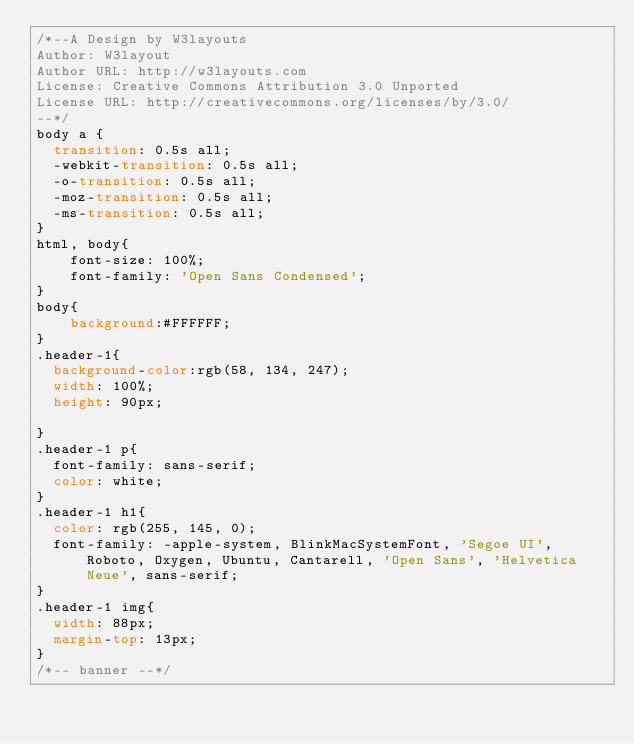Convert code to text. <code><loc_0><loc_0><loc_500><loc_500><_CSS_>/*--A Design by W3layouts 
Author: W3layout
Author URL: http://w3layouts.com
License: Creative Commons Attribution 3.0 Unported
License URL: http://creativecommons.org/licenses/by/3.0/
--*/
body a {
  transition: 0.5s all;
  -webkit-transition: 0.5s all;
  -o-transition: 0.5s all;
  -moz-transition: 0.5s all;
  -ms-transition: 0.5s all;
}
html, body{
    font-size: 100%;
	font-family: 'Open Sans Condensed';
}
body{
	background:#FFFFFF;
}
.header-1{
  background-color:rgb(58, 134, 247);
  width: 100%;
  height: 90px;
  
}
.header-1 p{
  font-family: sans-serif;
  color: white;
}
.header-1 h1{
  color: rgb(255, 145, 0);
  font-family: -apple-system, BlinkMacSystemFont, 'Segoe UI', Roboto, Oxygen, Ubuntu, Cantarell, 'Open Sans', 'Helvetica Neue', sans-serif;
}
.header-1 img{
  width: 88px;
  margin-top: 13px;
}
/*-- banner --*/</code> 